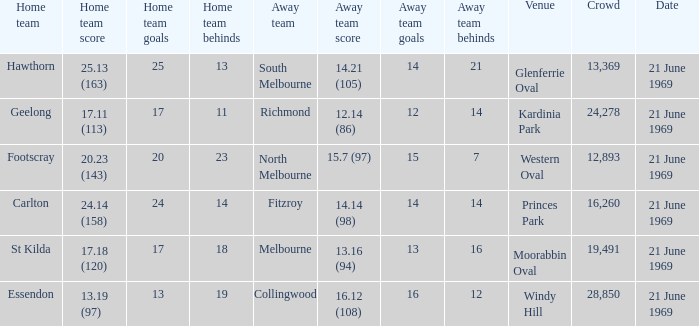When did an away team score 15.7 (97)? 21 June 1969. Can you parse all the data within this table? {'header': ['Home team', 'Home team score', 'Home team goals', 'Home team behinds', 'Away team', 'Away team score', 'Away team goals', 'Away team behinds', 'Venue', 'Crowd', 'Date'], 'rows': [['Hawthorn', '25.13 (163)', '25', '13', 'South Melbourne', '14.21 (105)', '14', '21', 'Glenferrie Oval', '13,369', '21 June 1969'], ['Geelong', '17.11 (113)', '17', '11', 'Richmond', '12.14 (86)', '12', '14', 'Kardinia Park', '24,278', '21 June 1969'], ['Footscray', '20.23 (143)', '20', '23', 'North Melbourne', '15.7 (97)', '15', '7', 'Western Oval', '12,893', '21 June 1969'], ['Carlton', '24.14 (158)', '24', '14', 'Fitzroy', '14.14 (98)', '14', '14', 'Princes Park', '16,260', '21 June 1969'], ['St Kilda', '17.18 (120)', '17', '18', 'Melbourne', '13.16 (94)', '13', '16', 'Moorabbin Oval', '19,491', '21 June 1969'], ['Essendon', '13.19 (97)', '13', '19', 'Collingwood', '16.12 (108)', '16', '12', 'Windy Hill', '28,850', '21 June 1969']]} 